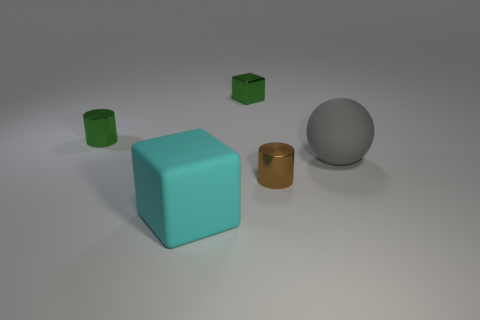What number of other things are the same color as the big ball?
Offer a very short reply. 0. Is the number of brown blocks less than the number of cyan matte cubes?
Keep it short and to the point. Yes. What number of matte objects are left of the metal cylinder right of the cylinder that is behind the tiny brown thing?
Keep it short and to the point. 1. What is the size of the cylinder that is to the right of the cyan rubber object?
Give a very brief answer. Small. Does the thing on the left side of the matte block have the same shape as the brown thing?
Ensure brevity in your answer.  Yes. Are there any other things that are the same size as the green cylinder?
Offer a terse response. Yes. Are there any matte blocks?
Provide a short and direct response. Yes. There is a cube that is right of the matte thing that is in front of the big rubber object that is behind the small brown cylinder; what is it made of?
Give a very brief answer. Metal. Does the tiny brown metal object have the same shape as the green thing on the left side of the large cyan block?
Keep it short and to the point. Yes. What number of other things have the same shape as the cyan thing?
Your answer should be compact. 1. 